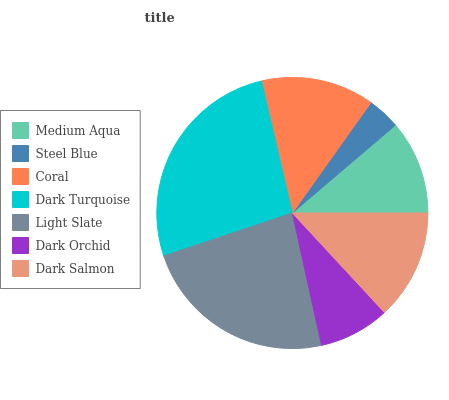Is Steel Blue the minimum?
Answer yes or no. Yes. Is Dark Turquoise the maximum?
Answer yes or no. Yes. Is Coral the minimum?
Answer yes or no. No. Is Coral the maximum?
Answer yes or no. No. Is Coral greater than Steel Blue?
Answer yes or no. Yes. Is Steel Blue less than Coral?
Answer yes or no. Yes. Is Steel Blue greater than Coral?
Answer yes or no. No. Is Coral less than Steel Blue?
Answer yes or no. No. Is Dark Salmon the high median?
Answer yes or no. Yes. Is Dark Salmon the low median?
Answer yes or no. Yes. Is Dark Turquoise the high median?
Answer yes or no. No. Is Steel Blue the low median?
Answer yes or no. No. 